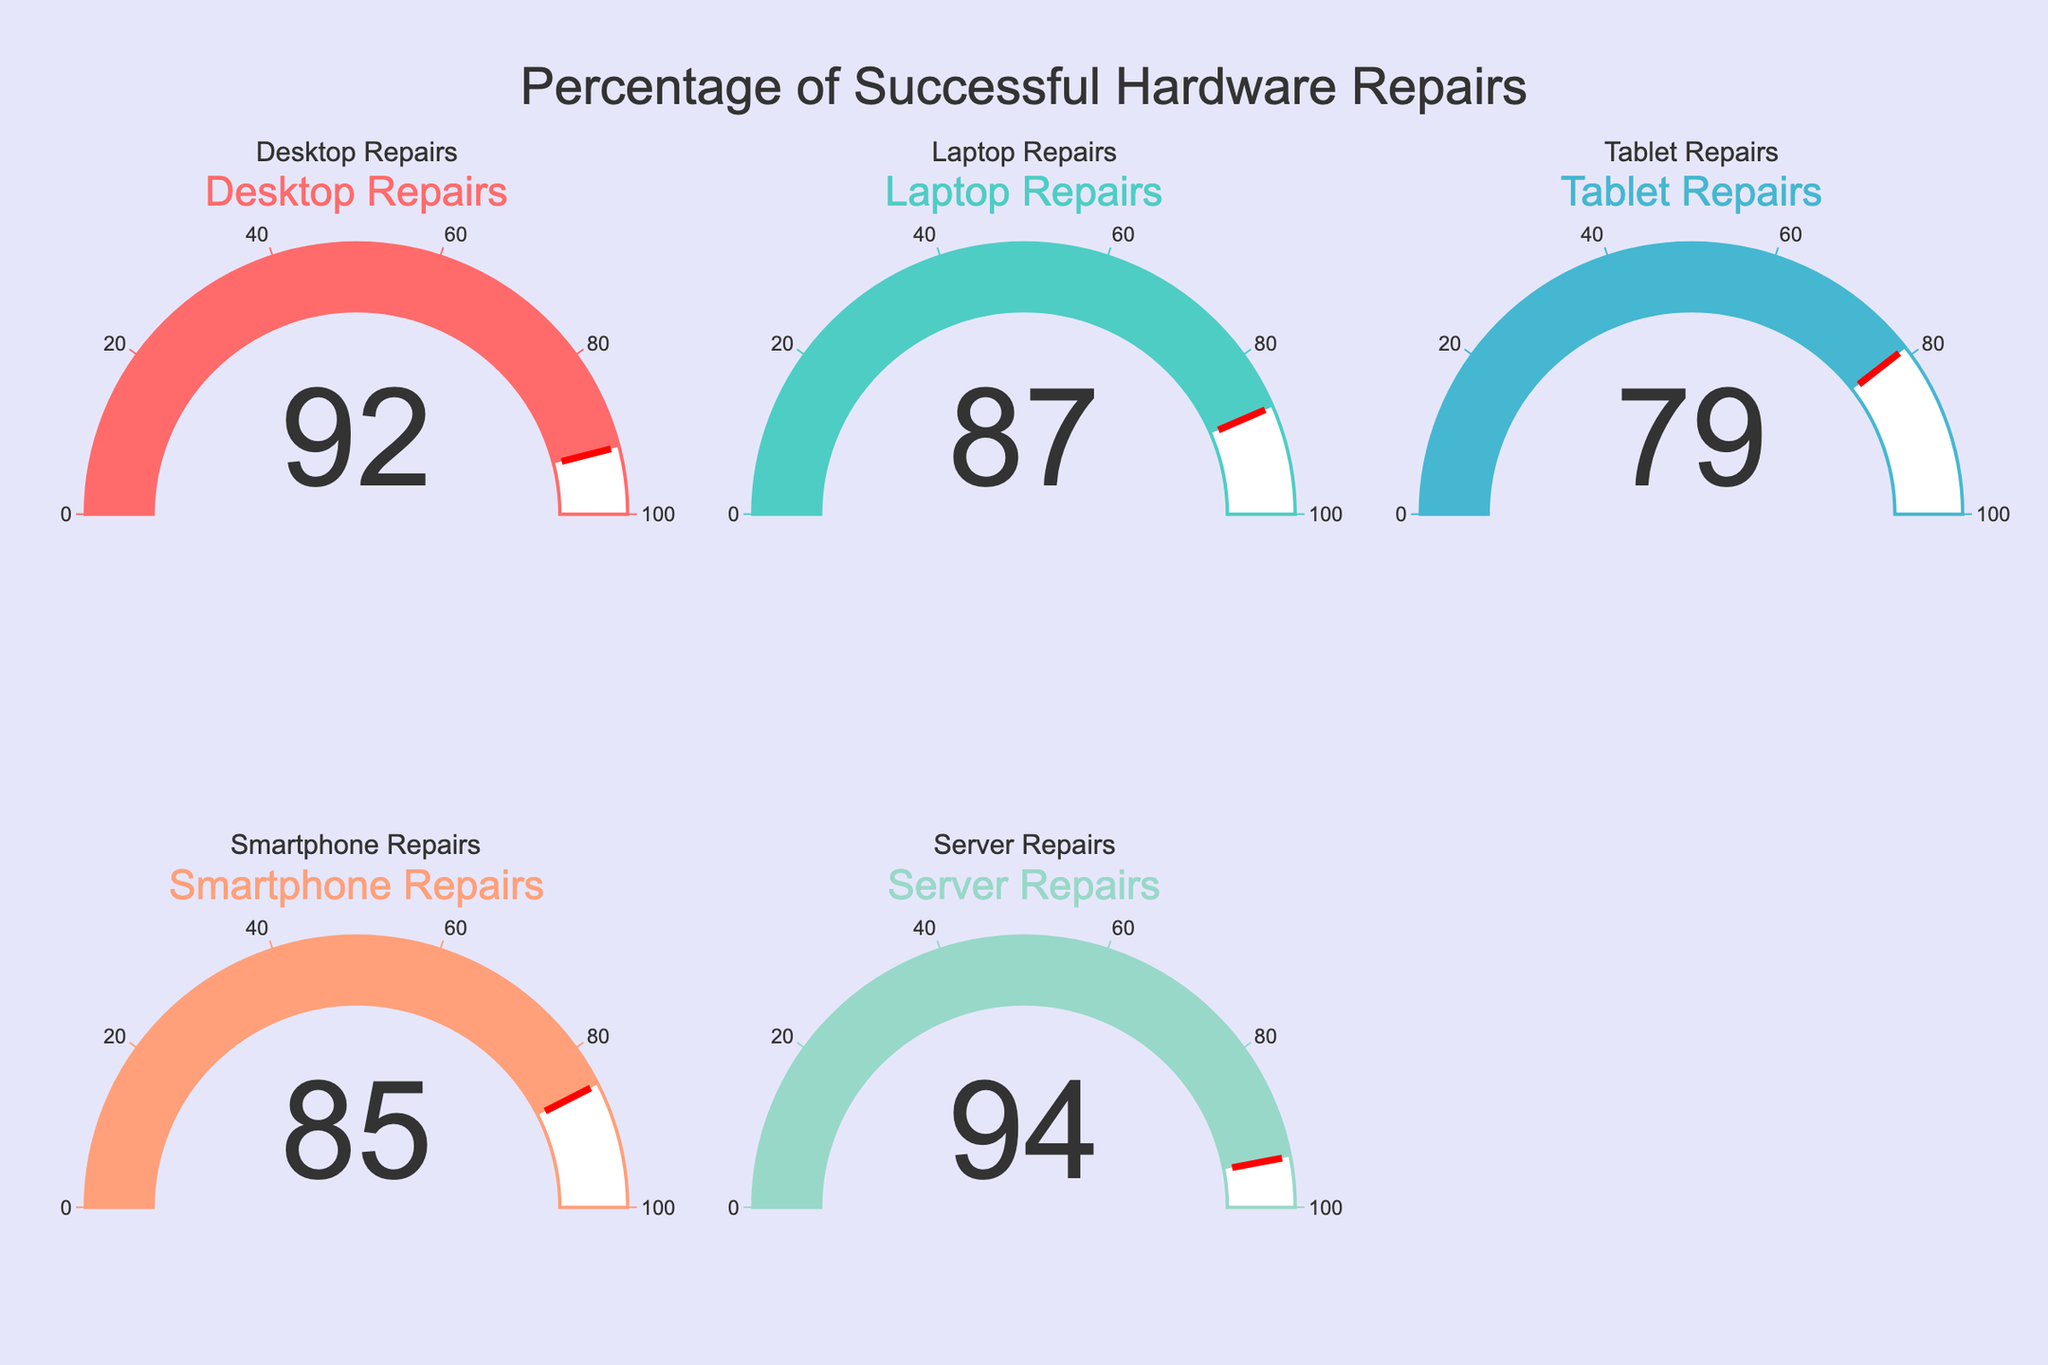Which hardware repair category has the highest percentage of successful repairs? The Server Repairs gauge shows the highest successful rate at 94%, as indicated by the gauge value.
Answer: Server Repairs What's the total percentage when combining successful Desktop and Laptop repairs? The Desktop Repairs percentage is 92 and the Laptop Repairs percentage is 87. Summing them up gives 92 + 87 = 179.
Answer: 179 Which category has a lower percentage of successful repairs, Tablets or Smartphones? The Tablet Repairs gauge shows 79% and the Smartphone Repairs gauge shows 85%. Since 79% is less than 85%, Tablet Repairs has a lower percentage.
Answer: Tablet Repairs How many categories have a success rate over 85%? The categories with a success rate over 85% are Desktop Repairs (92%), Laptop Repairs (87%), Smartphone Repairs (85%), and Server Repairs (94%). This gives us a total of 4 categories.
Answer: 4 What is the average percentage of successful repairs across all categories? Summing the percentages: 92 + 87 + 79 + 85 + 94 = 437. The number of categories is 5. Therefore, the average is 437 / 5 = 87.4.
Answer: 87.4 Compare the difference between the highest and the lowest repair success percentages. The highest percentage is 94 and the lowest is 79. Subtracting them gives 94 - 79 = 15.
Answer: 15 Which categories have a success rate between 80% and 90%? Laptop Repairs (87%) and Smartphone Repairs (85%) fall within the 80%-90% range.
Answer: Laptop Repairs and Smartphone Repairs Do Desktop Repairs or Server Repairs have a higher success rate? The Desktop Repairs gauge shows 92% and the Server Repairs gauge shows 94%. Since 94% is greater than 92%, Server Repairs have a higher success rate.
Answer: Server Repairs How does the success rate of Desktop Repairs compare to Smartphone Repairs? The Desktop Repairs gauge shows 92%, while the Smartphone Repairs gauge shows 85%. Since 92% is higher than 85%, Desktop Repairs have a higher success rate.
Answer: Desktop Repairs 